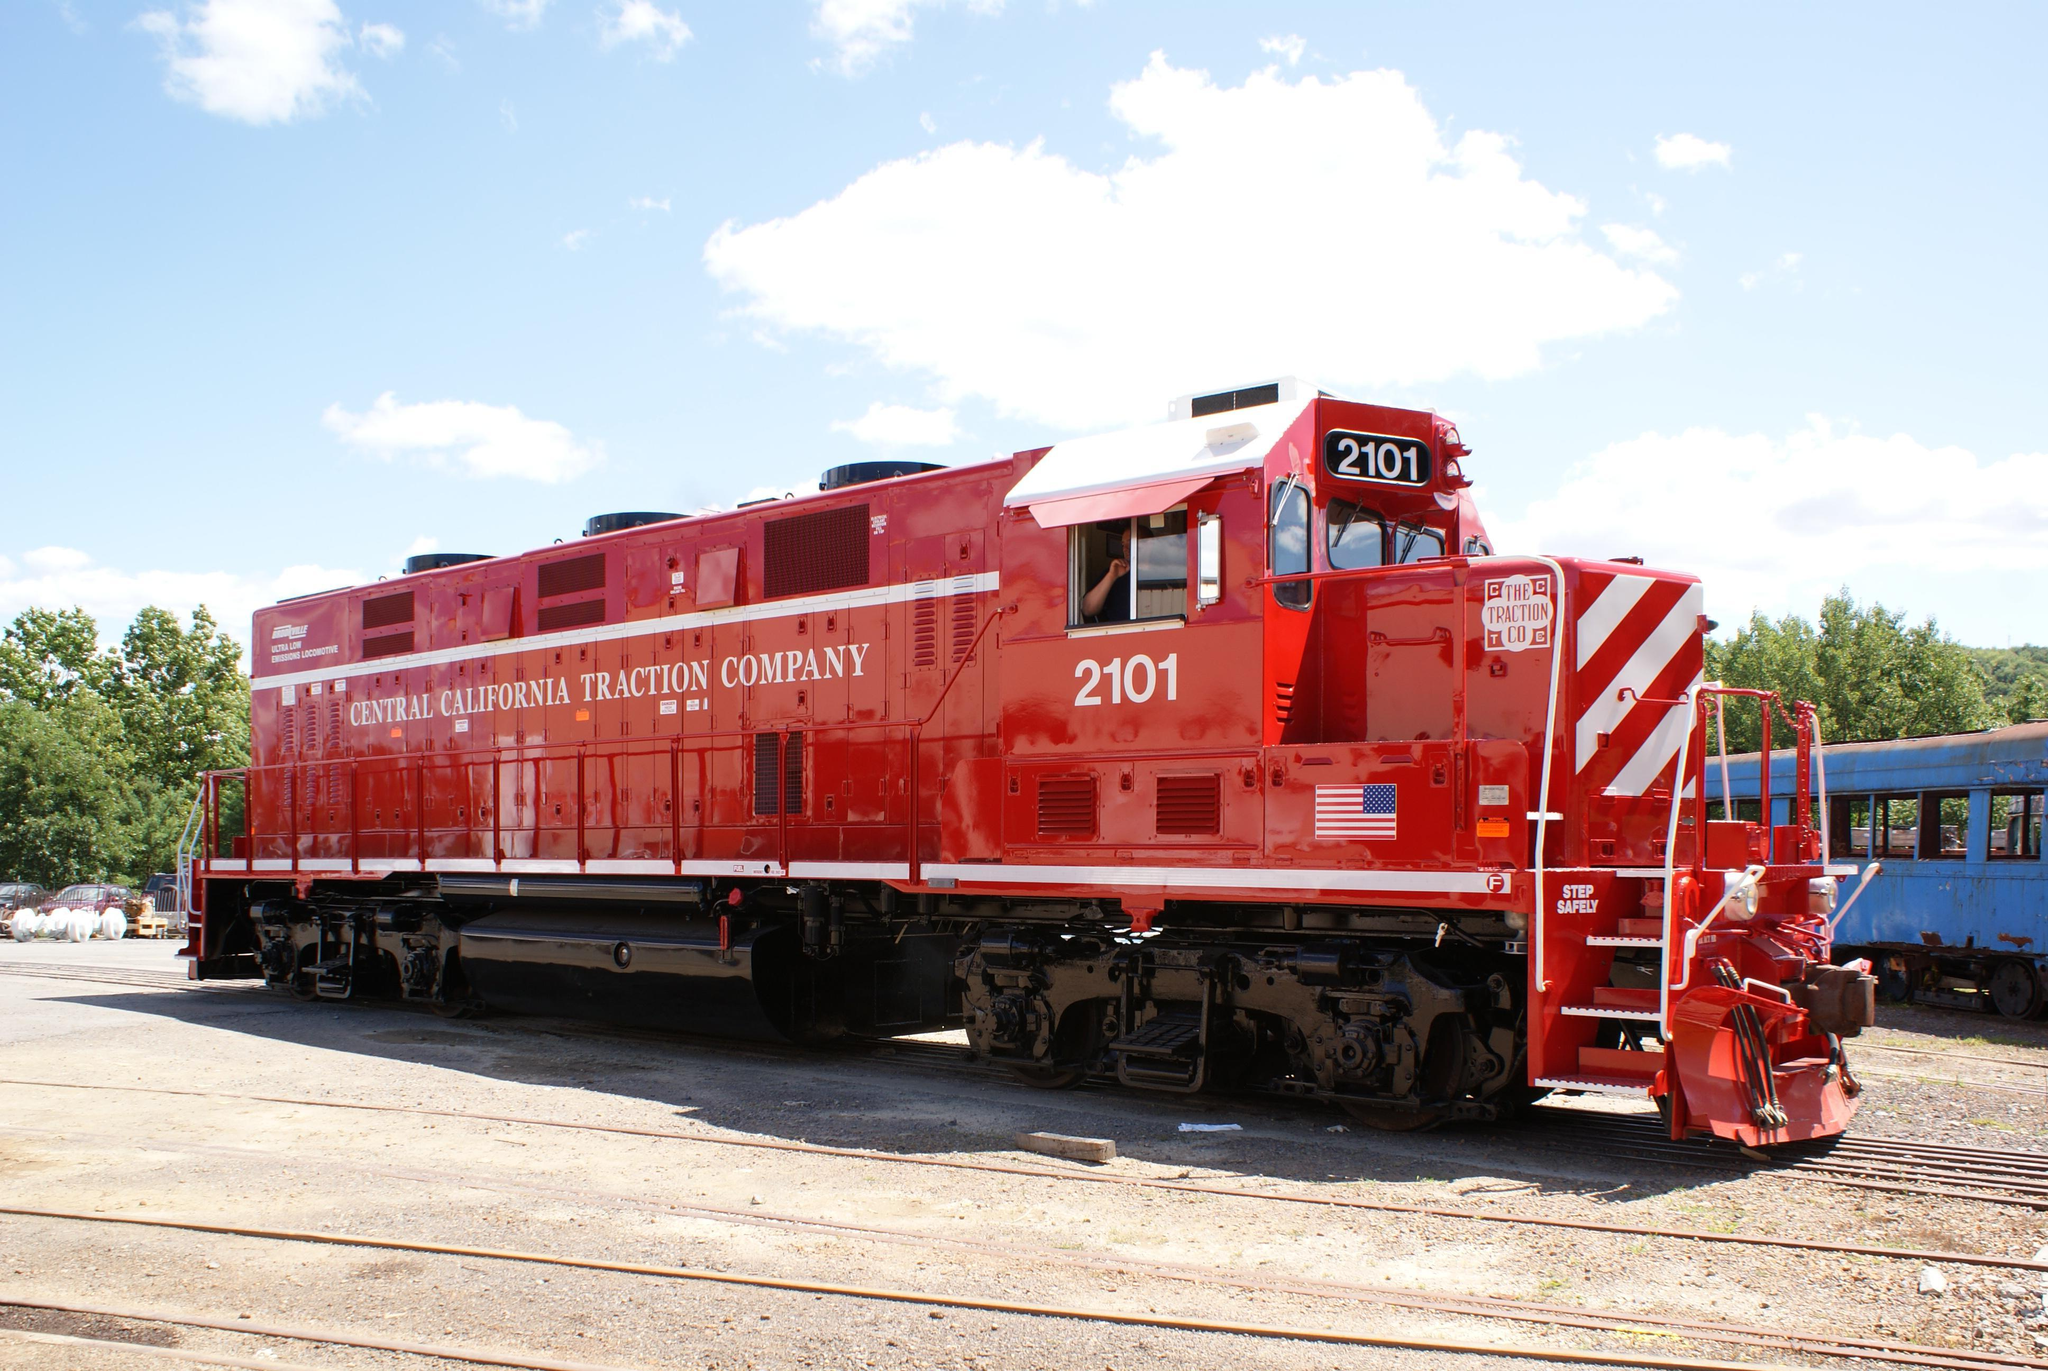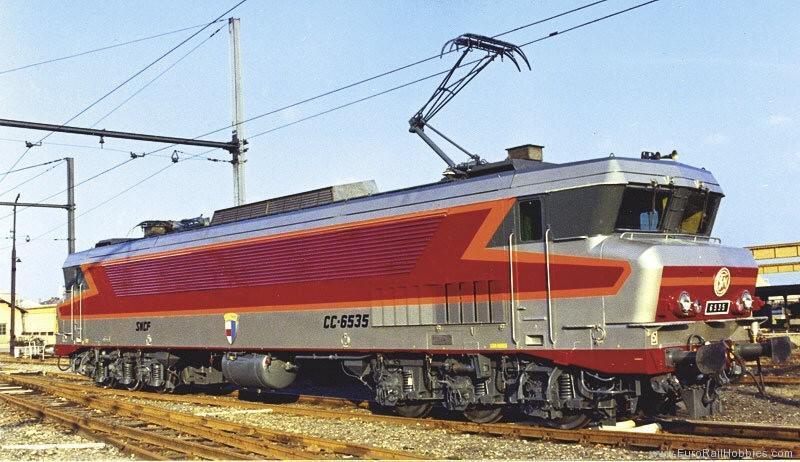The first image is the image on the left, the second image is the image on the right. Assess this claim about the two images: "There are at least four train cars in the image on the right.". Correct or not? Answer yes or no. No. 